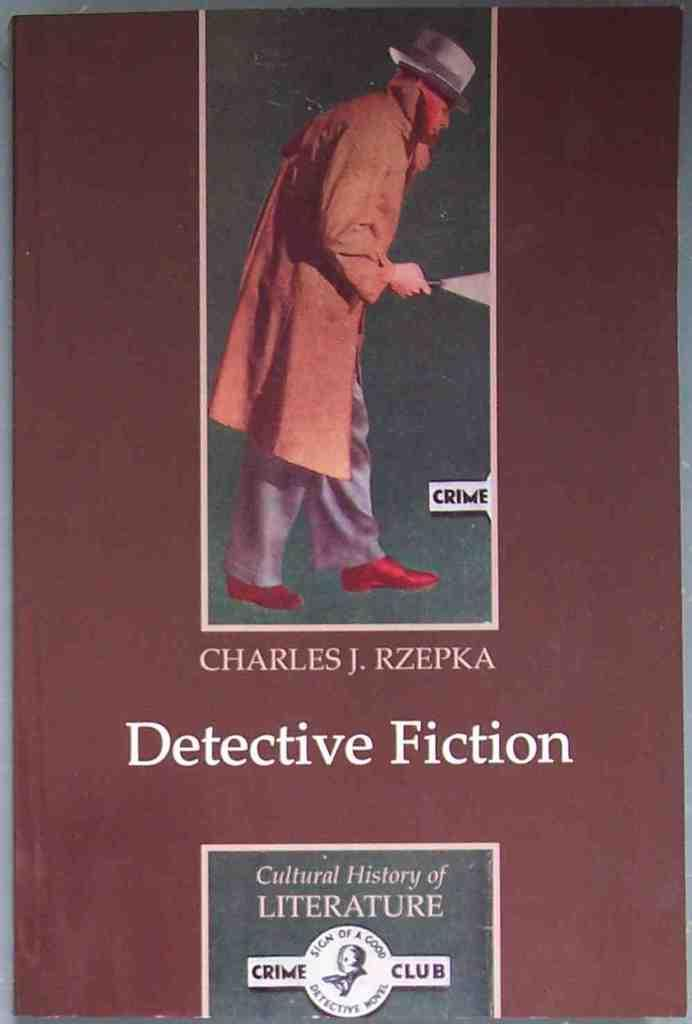What is featured on the poster in the picture? There is a picture of a man on the poster. What else can be seen on the poster besides the image? There is text on the poster. Is there any other identifying feature on the poster? Yes, there is a logo at the bottom of the poster. Can you describe the ship that is sailing in the background of the poster? There is no ship present in the image; the poster features a picture of a man with text and a logo. 